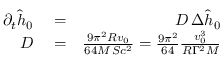<formula> <loc_0><loc_0><loc_500><loc_500>\begin{array} { r l r } { \partial _ { t } \hat { h } _ { 0 } } & = } & { D \, \Delta \hat { h } _ { 0 } } \\ { D } & = } & { { \frac { 9 \pi ^ { 2 } R v _ { 0 } } { 6 4 M \, S c ^ { 2 } } } = { \frac { 9 \pi ^ { 2 } } { 6 4 } } { \frac { v _ { 0 } ^ { 3 } } { R \Gamma ^ { 2 } M } } } \end{array}</formula> 